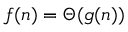Convert formula to latex. <formula><loc_0><loc_0><loc_500><loc_500>f ( n ) = \Theta ( g ( n ) )</formula> 